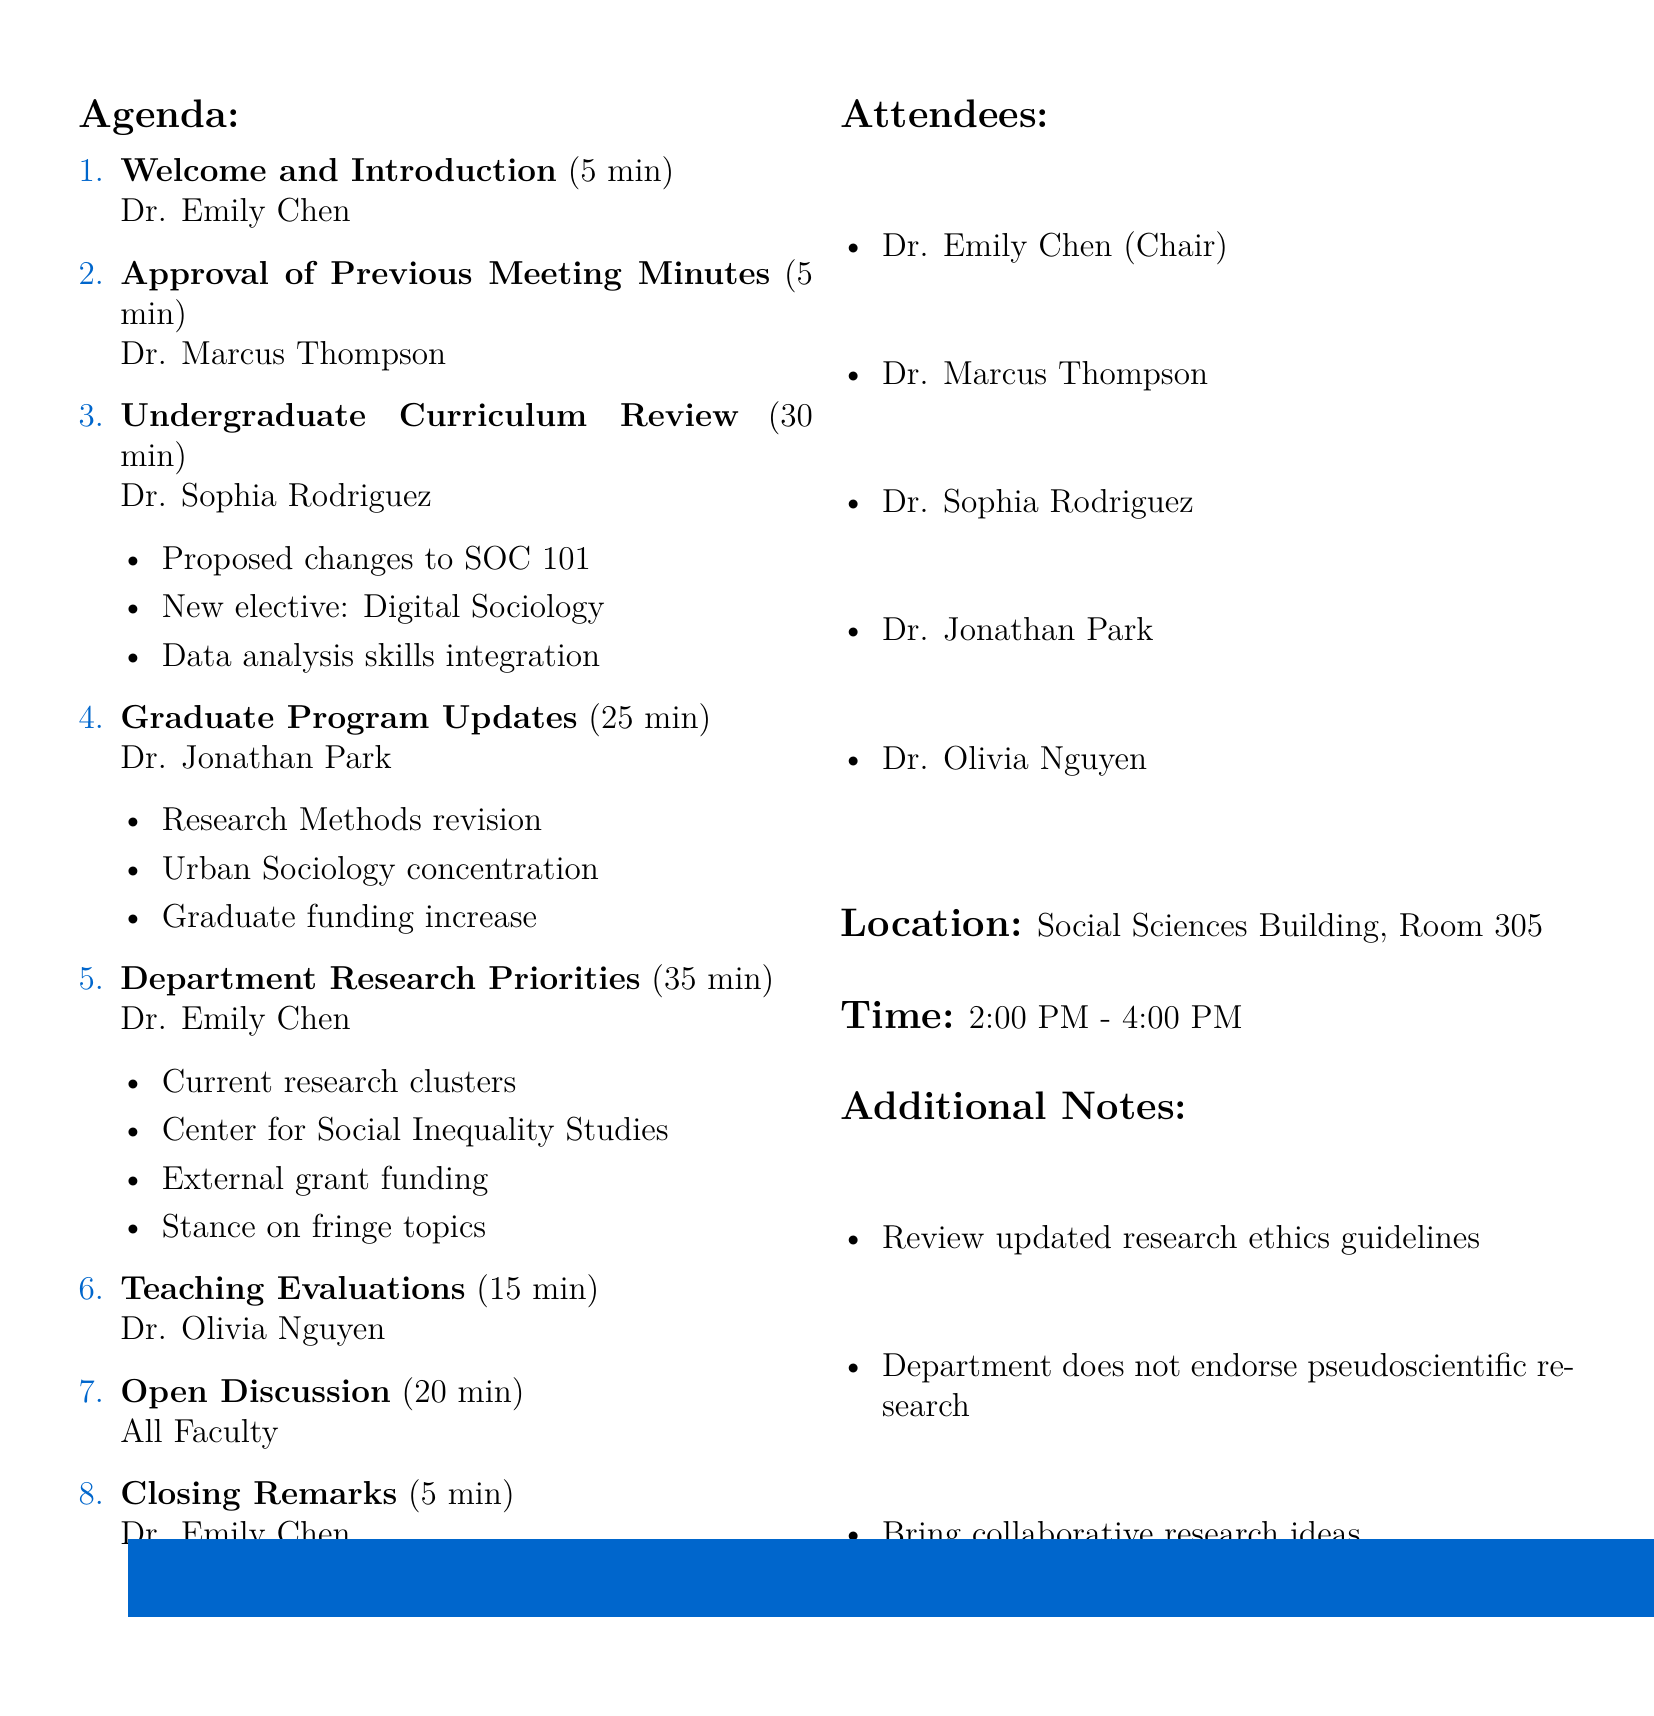What is the title of the meeting? The title of the meeting is explicitly stated at the beginning of the document.
Answer: Sociology Department Faculty Meeting: Curriculum Updates and Research Priorities Who is presenting the Undergraduate Curriculum Review? The document lists presenters for each agenda item, including the Undergraduate Curriculum Review.
Answer: Dr. Sophia Rodriguez How long is the discussion on Department Research Priorities scheduled? The duration for each agenda item is provided, allowing for the calculation of the total time allocated.
Answer: 35 minutes What is the location of the meeting? The document clearly states the location of the meeting for attendees.
Answer: Social Sciences Building, Room 305 What date is the faculty meeting scheduled for? The document includes the date at the top, highlighting its significance.
Answer: May 15, 2023 What new course is proposed in the Undergraduate Curriculum Review? The document outlines specific subtopics under the Undergraduate Curriculum Review, including proposed courses.
Answer: Digital Sociology and Social Media Who is responsible for the Closing Remarks? The presenter of the Closing Remarks is indicated in the agenda items.
Answer: Dr. Emily Chen What is one of the additional notes regarding the department’s research stance? The document includes notes that set expectations for faculty in regard to research topics.
Answer: Does not support or endorse research into pseudoscientific topics How long is the Open Discussion scheduled for? The duration for each agenda item is specified, making it easy to find the time allocated for discussions.
Answer: 20 minutes 